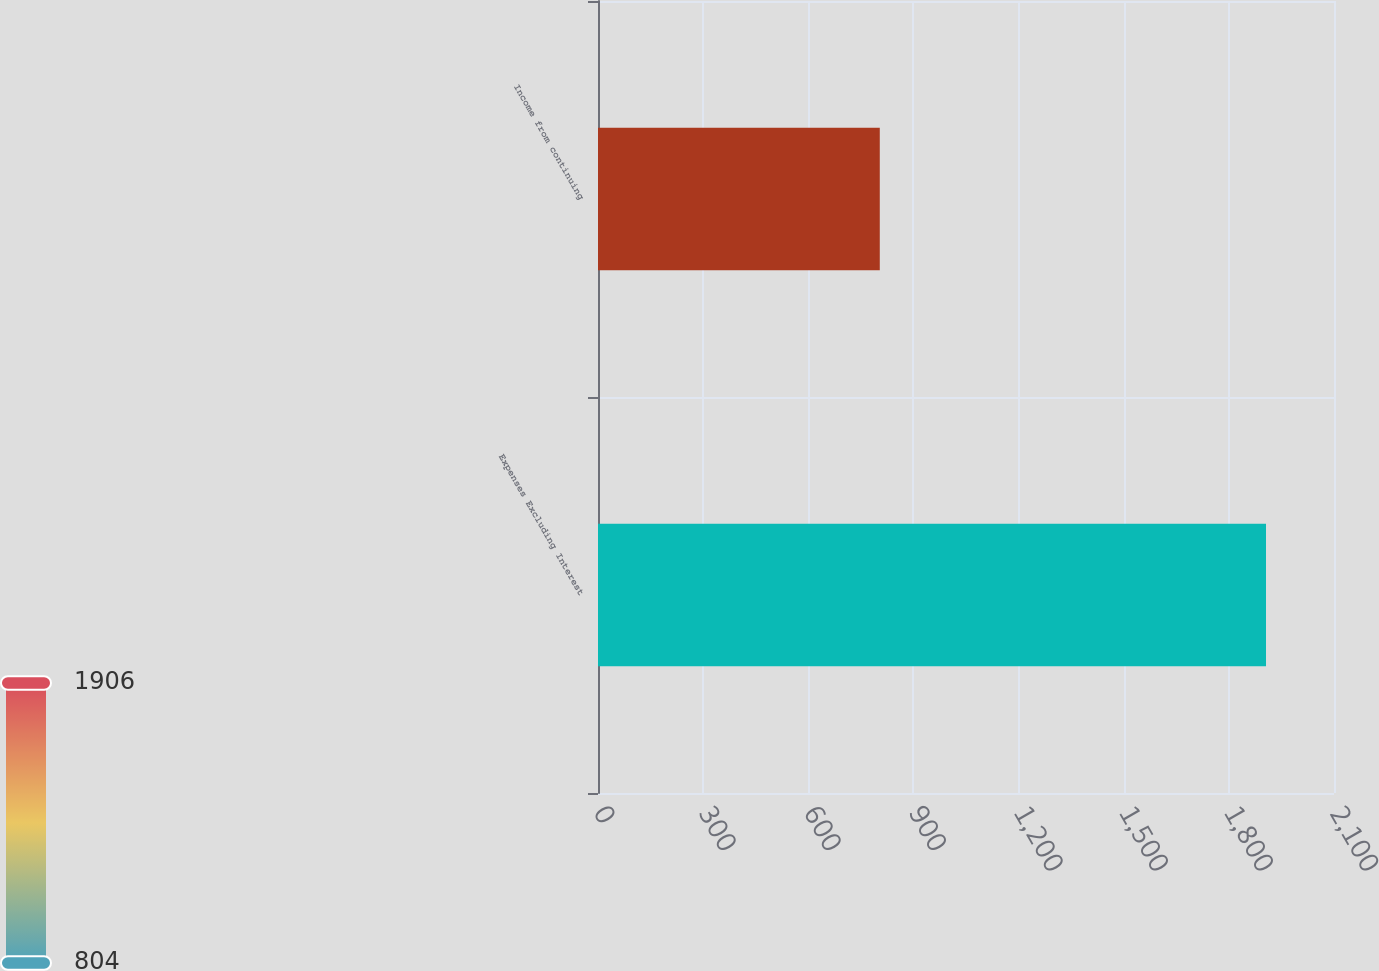<chart> <loc_0><loc_0><loc_500><loc_500><bar_chart><fcel>Expenses Excluding Interest<fcel>Income from continuing<nl><fcel>1906<fcel>804<nl></chart> 